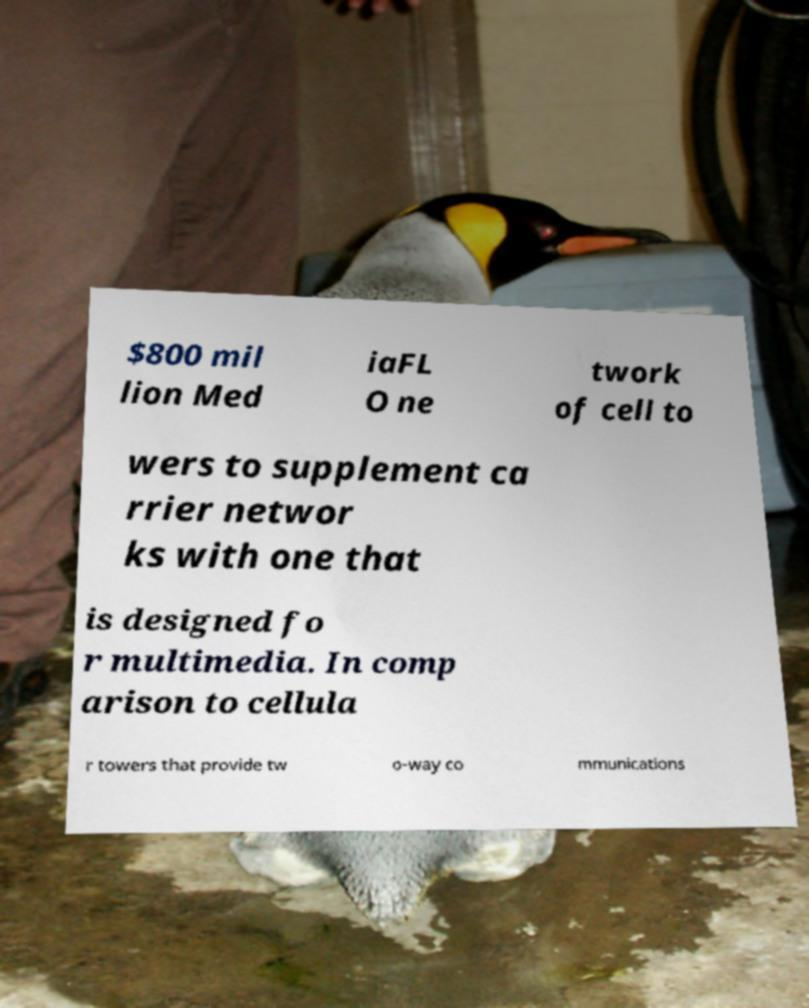Please identify and transcribe the text found in this image. $800 mil lion Med iaFL O ne twork of cell to wers to supplement ca rrier networ ks with one that is designed fo r multimedia. In comp arison to cellula r towers that provide tw o-way co mmunications 